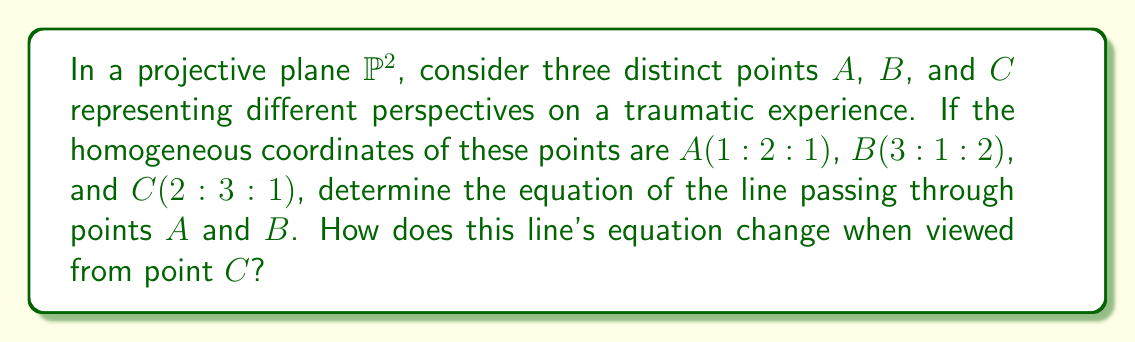What is the answer to this math problem? 1) To find the equation of the line passing through points $A$ and $B$, we can use the determinant method:

   $$\begin{vmatrix}
   x & y & z \\
   1 & 2 & 1 \\
   3 & 1 & 2
   \end{vmatrix} = 0$$

2) Expanding the determinant:
   $$(2z - y) - (x - 3z) + (3x - 2y) = 0$$

3) Simplifying:
   $$2z - y - x + 3z + 3x - 2y = 0$$
   $$4x - 3y + 5z = 0$$

4) This is the equation of the line passing through $A$ and $B$ in the projective plane.

5) To view this line from point $C(2:3:1)$, we need to perform a projective transformation that maps $C$ to the point at infinity $(0:0:1)$. This can be achieved by multiplying the coordinates by the inverse of the matrix:

   $$M = \begin{pmatrix}
   2 & 3 & 1 \\
   0 & 1 & 0 \\
   0 & 0 & 1
   \end{pmatrix}$$

6) The inverse of $M$ is:

   $$M^{-1} = \begin{pmatrix}
   1/2 & -3/2 & 0 \\
   0 & 1 & 0 \\
   0 & 0 & 1
   \end{pmatrix}$$

7) Applying this transformation to the line equation:

   $$(4x - 3y + 5z) \cdot M^{-1} = (2x - 6y + 5z : 4x - 3y + 5z : 4x - 3y + 5z)$$

8) Simplifying and removing the last coordinate (which becomes 0 at infinity):

   $$(2x - 6y + 5z : 4x - 3y + 5z)$$

This represents the line equation when viewed from point $C$.
Answer: Original line: $4x - 3y + 5z = 0$; From $C$: $(2x - 6y + 5z : 4x - 3y + 5z)$ 